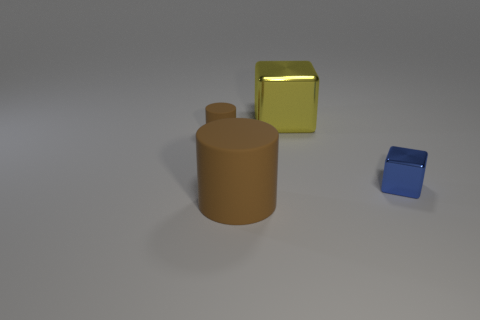There is a big cylinder; are there any brown cylinders on the right side of it?
Give a very brief answer. No. Are the cube that is in front of the large yellow metallic cube and the small thing that is on the left side of the large yellow shiny block made of the same material?
Your answer should be very brief. No. Is the number of yellow shiny cubes behind the large yellow cube less than the number of large green metal objects?
Give a very brief answer. No. There is a cylinder behind the tiny blue thing; what is its color?
Give a very brief answer. Brown. What material is the big thing right of the brown thing in front of the small metallic cube made of?
Make the answer very short. Metal. Is there a purple cylinder of the same size as the blue cube?
Keep it short and to the point. No. What number of objects are large things on the left side of the yellow object or things behind the big brown cylinder?
Give a very brief answer. 4. Is the size of the metallic thing in front of the big block the same as the brown object that is behind the small block?
Provide a succinct answer. Yes. There is a block that is on the left side of the blue metallic block; is there a large rubber object that is left of it?
Your answer should be very brief. Yes. There is a small cube; what number of brown cylinders are behind it?
Ensure brevity in your answer.  1. 